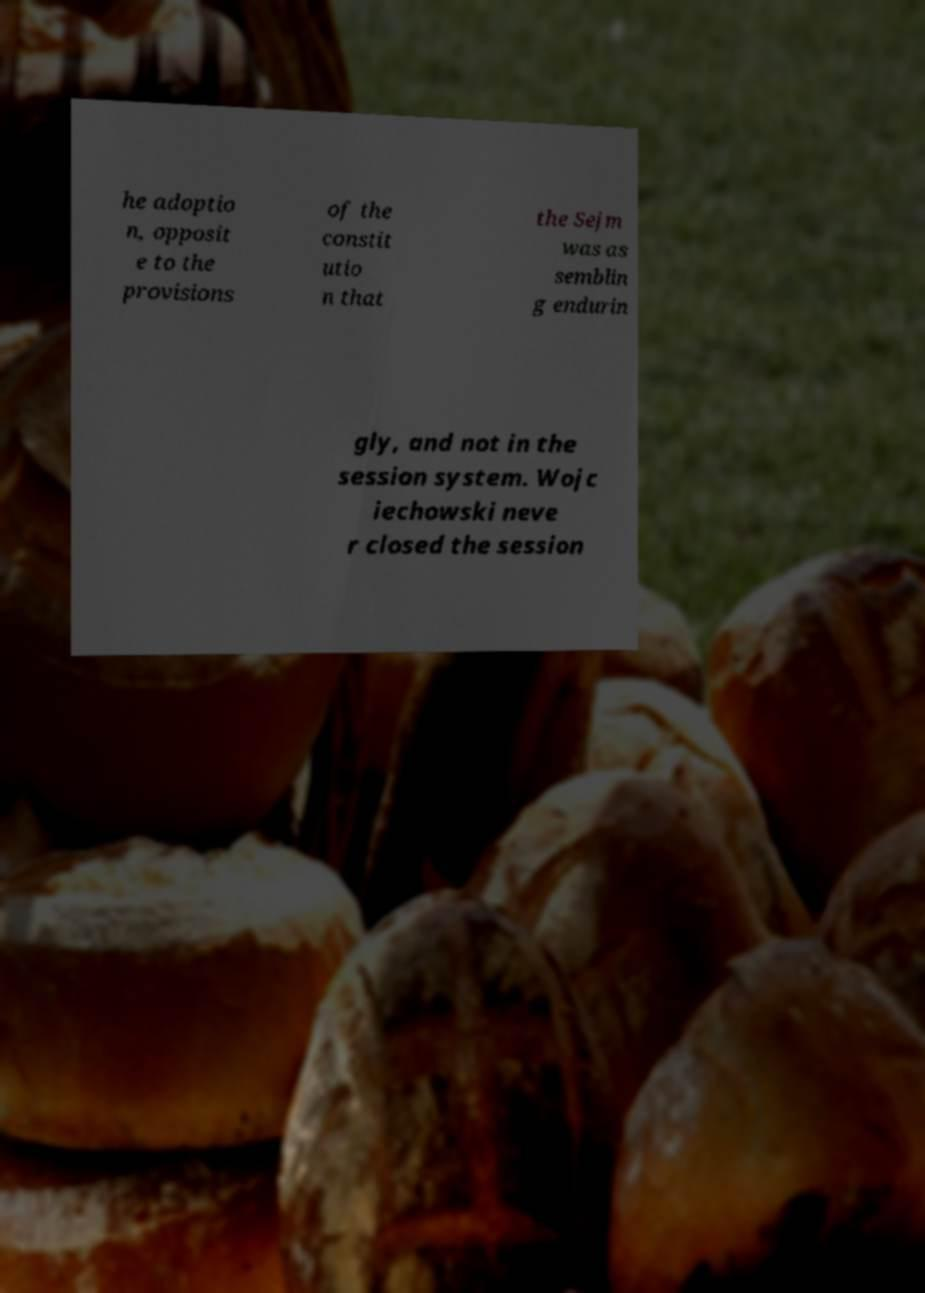For documentation purposes, I need the text within this image transcribed. Could you provide that? he adoptio n, opposit e to the provisions of the constit utio n that the Sejm was as semblin g endurin gly, and not in the session system. Wojc iechowski neve r closed the session 